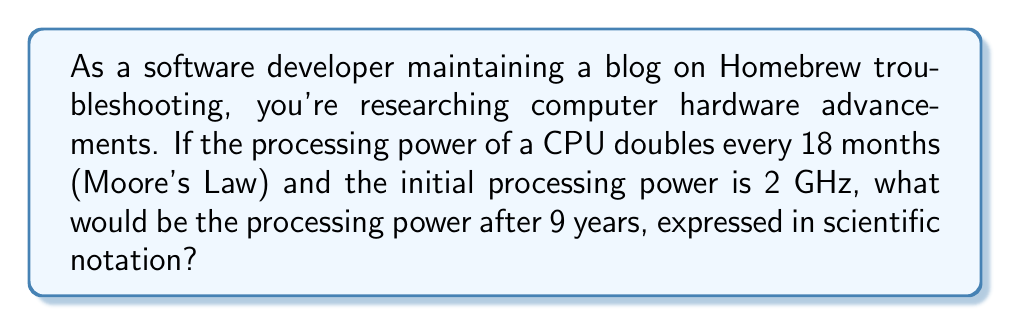Teach me how to tackle this problem. Let's approach this step-by-step:

1) First, we need to determine how many 18-month periods are in 9 years:
   $$ \frac{9 \text{ years} \times 12 \text{ months/year}}{18 \text{ months/period}} = 6 \text{ periods} $$

2) Now, we know that the processing power doubles every period. This means we're dealing with exponential growth. The formula is:

   $$ P = P_0 \times 2^n $$

   Where $P$ is the final processing power, $P_0$ is the initial processing power, and $n$ is the number of periods.

3) We can plug in our values:
   $$ P = 2 \text{ GHz} \times 2^6 $$

4) Let's calculate $2^6$:
   $$ 2^6 = 64 $$

5) Now our equation looks like:
   $$ P = 2 \text{ GHz} \times 64 = 128 \text{ GHz} $$

6) To express this in scientific notation, we move the decimal point to the left until we have a number between 1 and 10, and then count how many places we moved:

   $$ 128 \text{ GHz} = 1.28 \times 10^2 \text{ GHz} $$

Therefore, the processing power after 9 years would be $1.28 \times 10^2$ GHz.
Answer: $1.28 \times 10^2$ GHz 